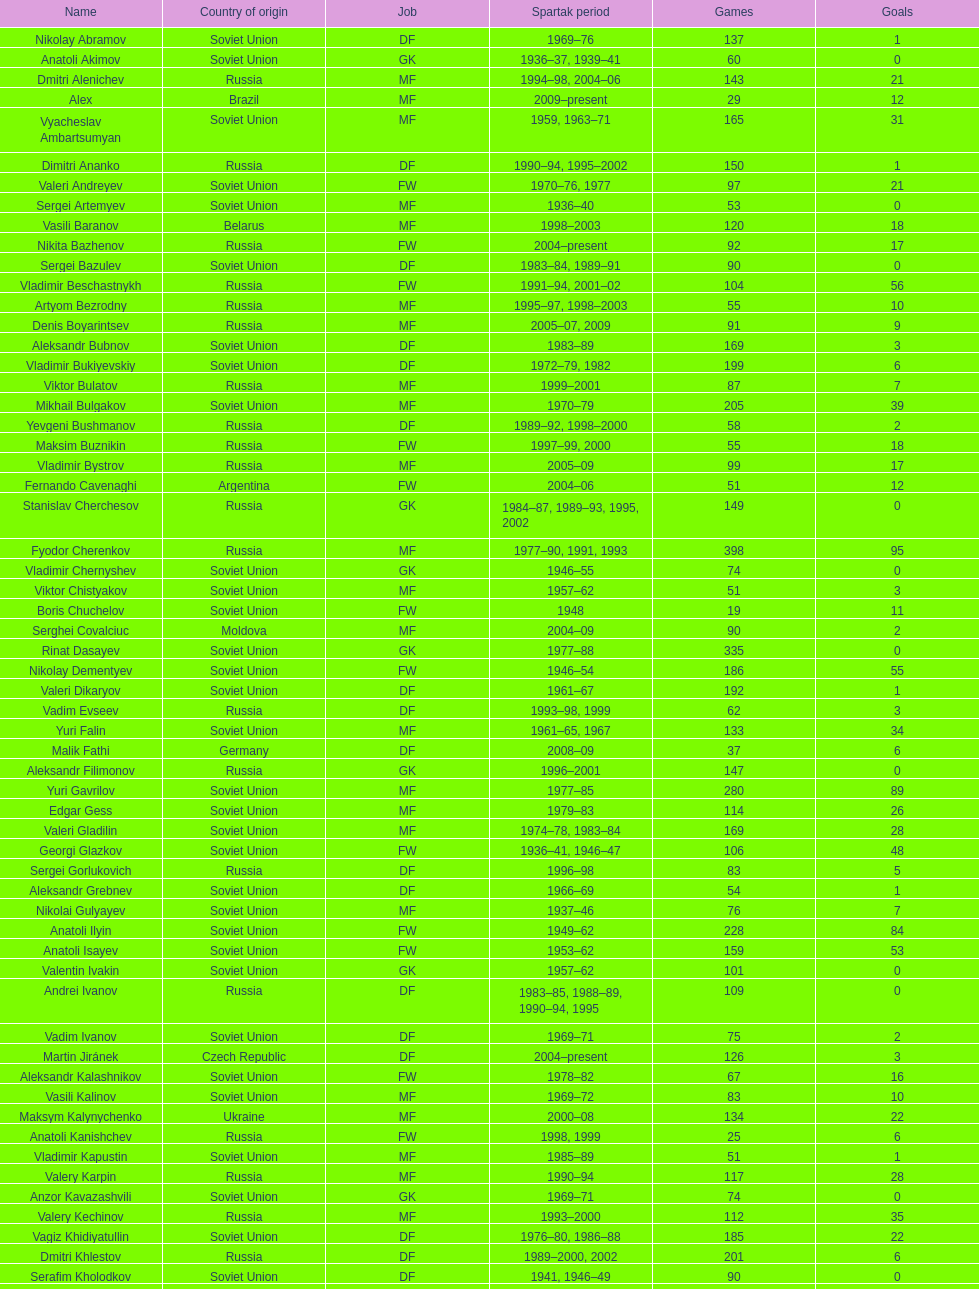Baranov has played from 2004 to the present. what is his nationality? Belarus. 